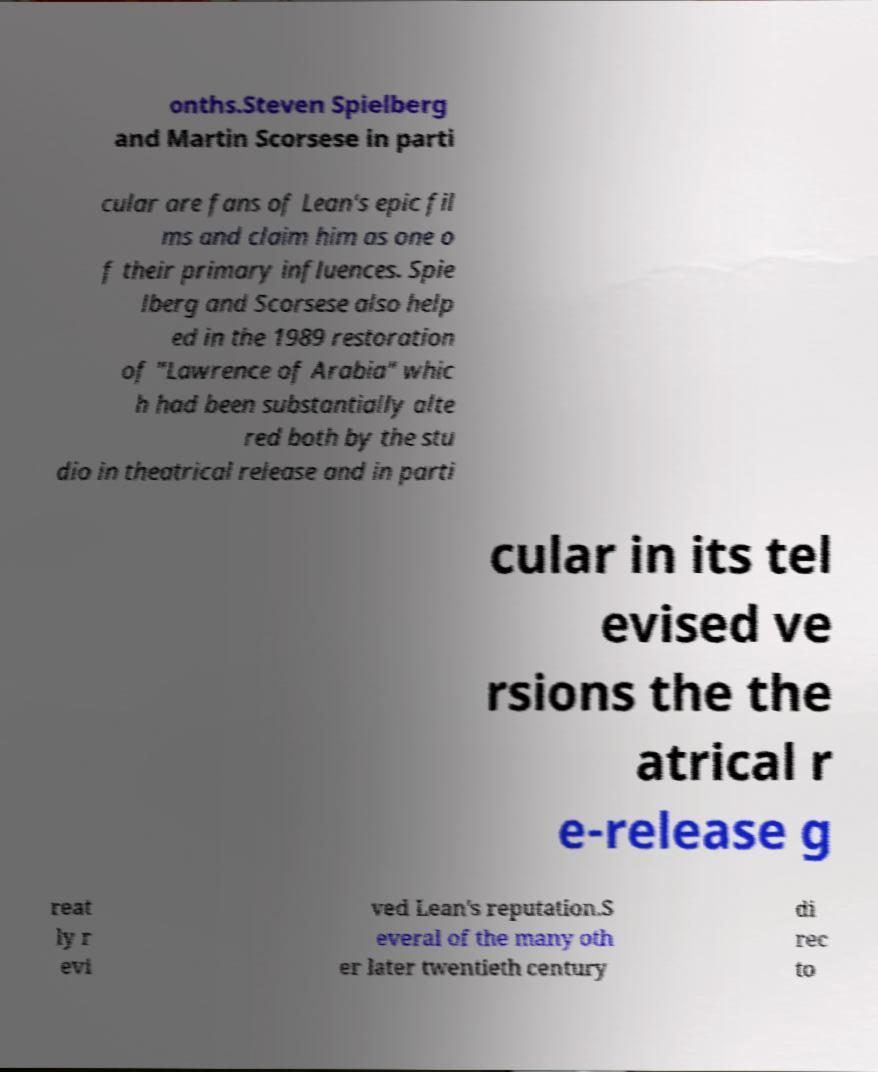What messages or text are displayed in this image? I need them in a readable, typed format. onths.Steven Spielberg and Martin Scorsese in parti cular are fans of Lean's epic fil ms and claim him as one o f their primary influences. Spie lberg and Scorsese also help ed in the 1989 restoration of "Lawrence of Arabia" whic h had been substantially alte red both by the stu dio in theatrical release and in parti cular in its tel evised ve rsions the the atrical r e-release g reat ly r evi ved Lean's reputation.S everal of the many oth er later twentieth century di rec to 